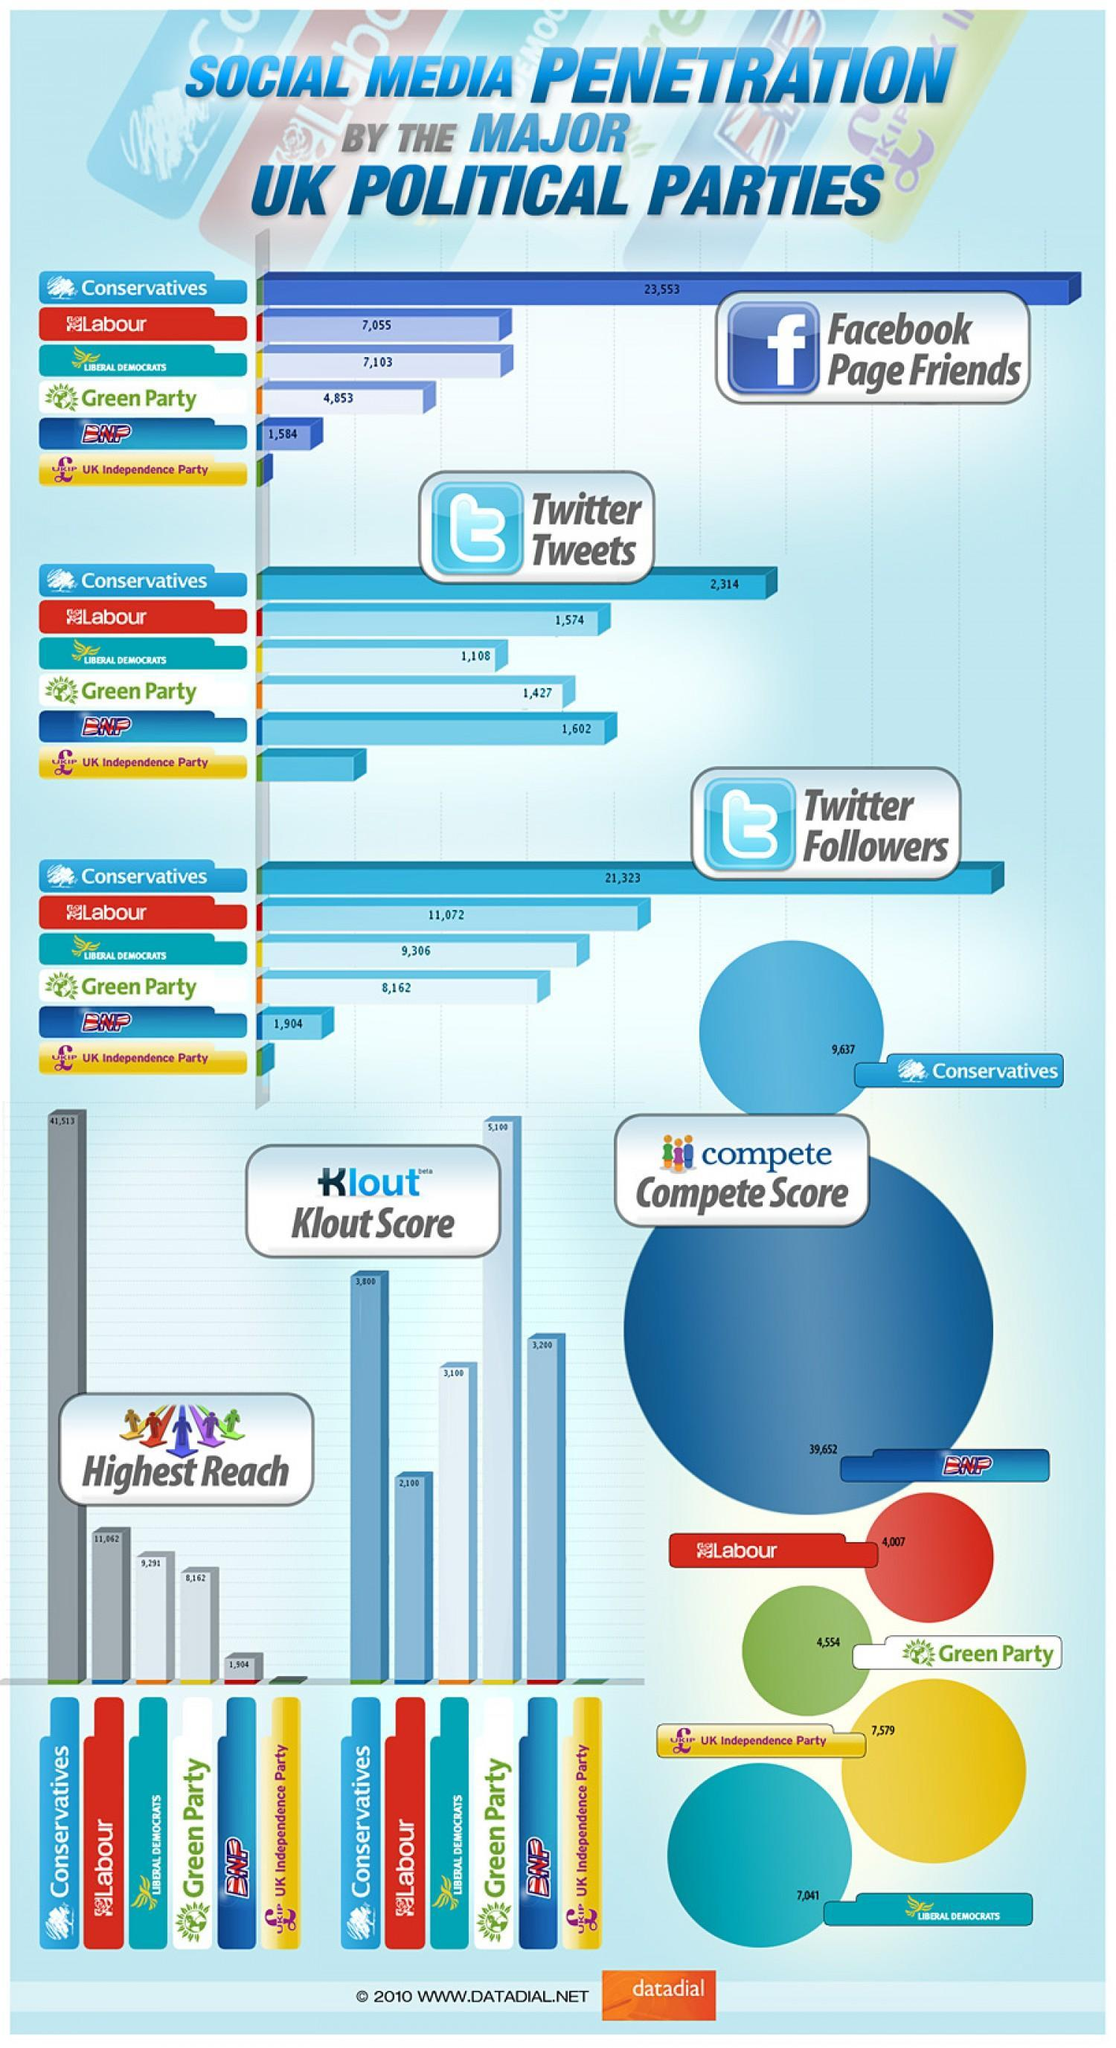WHat is the difference between the FB friends and twitter followers for Conservatives
Answer the question with a short phrase. 2230 what is the compete score for Labour 4007 Where does BNP have more followers / friends, FaceBook or twitter Twitter What colour is Labour shown in, red or yellow red Which is just below Conservatives in the number of Twitter Tweets BNP Which is the second lowest in Facebook penetration BNP 